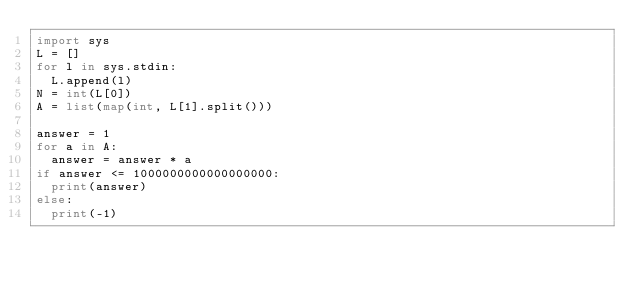<code> <loc_0><loc_0><loc_500><loc_500><_Python_>import sys
L = []
for l in sys.stdin:
  L.append(l)
N = int(L[0])
A = list(map(int, L[1].split()))

answer = 1
for a in A:
  answer = answer * a
if answer <= 1000000000000000000:
  print(answer)
else:
  print(-1)</code> 